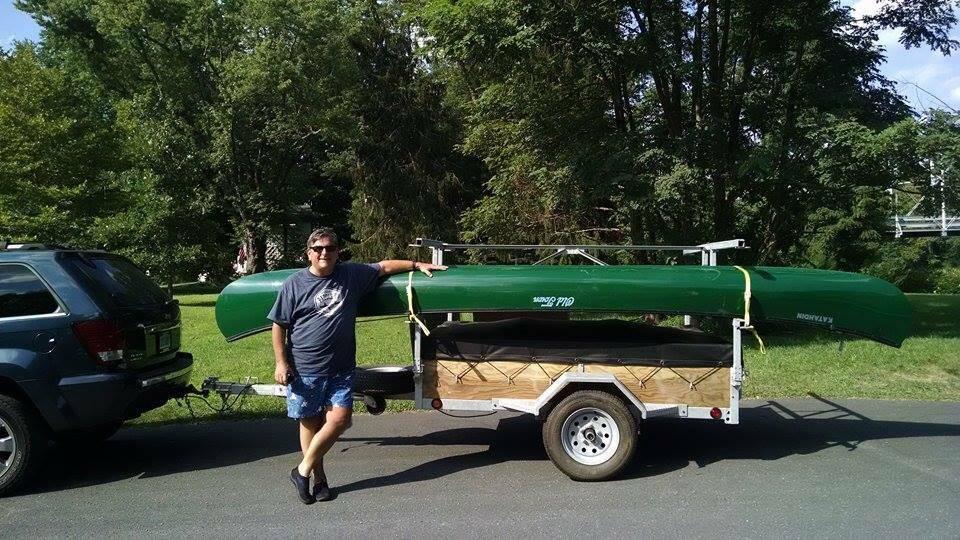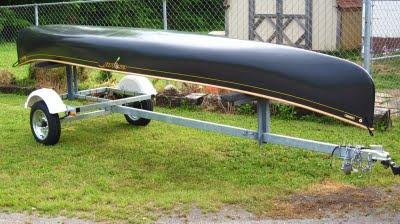The first image is the image on the left, the second image is the image on the right. Analyze the images presented: Is the assertion "There are at least four canoes loaded up to be transported elsewhere." valid? Answer yes or no. No. The first image is the image on the left, the second image is the image on the right. Considering the images on both sides, is "In one of the pictures, the canoe is attached to the back of a car." valid? Answer yes or no. Yes. 